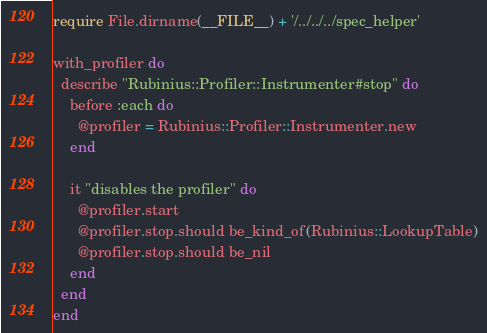Convert code to text. <code><loc_0><loc_0><loc_500><loc_500><_Ruby_>require File.dirname(__FILE__) + '/../../../spec_helper'

with_profiler do
  describe "Rubinius::Profiler::Instrumenter#stop" do
    before :each do
      @profiler = Rubinius::Profiler::Instrumenter.new
    end

    it "disables the profiler" do
      @profiler.start
      @profiler.stop.should be_kind_of(Rubinius::LookupTable)
      @profiler.stop.should be_nil
    end
  end
end
</code> 